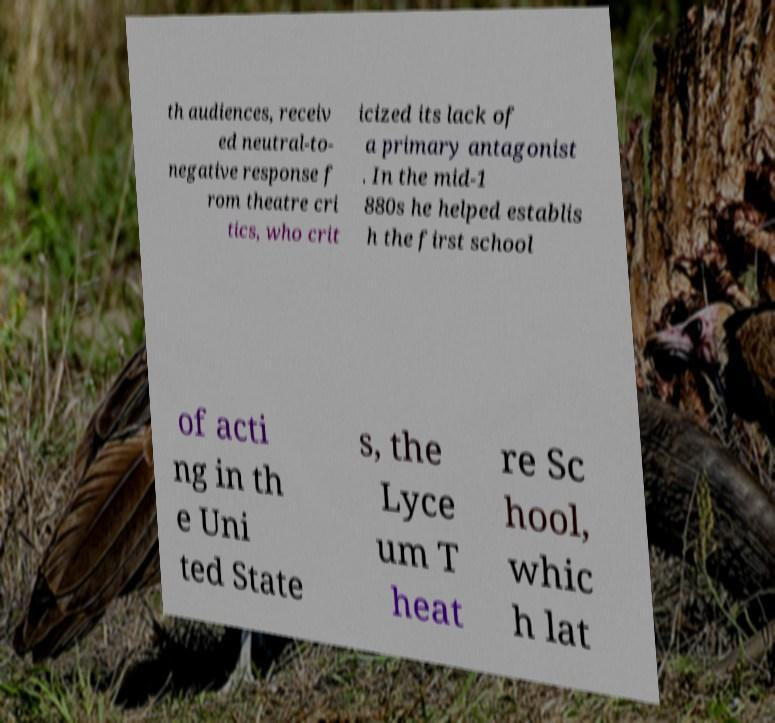For documentation purposes, I need the text within this image transcribed. Could you provide that? th audiences, receiv ed neutral-to- negative response f rom theatre cri tics, who crit icized its lack of a primary antagonist . In the mid-1 880s he helped establis h the first school of acti ng in th e Uni ted State s, the Lyce um T heat re Sc hool, whic h lat 